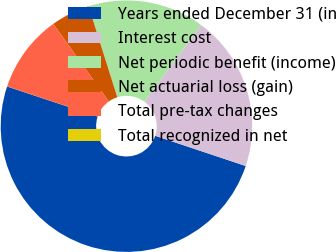Convert chart. <chart><loc_0><loc_0><loc_500><loc_500><pie_chart><fcel>Years ended December 31 (in<fcel>Interest cost<fcel>Net periodic benefit (income)<fcel>Net actuarial loss (gain)<fcel>Total pre-tax changes<fcel>Total recognized in net<nl><fcel>49.98%<fcel>20.0%<fcel>15.0%<fcel>5.01%<fcel>10.0%<fcel>0.01%<nl></chart> 